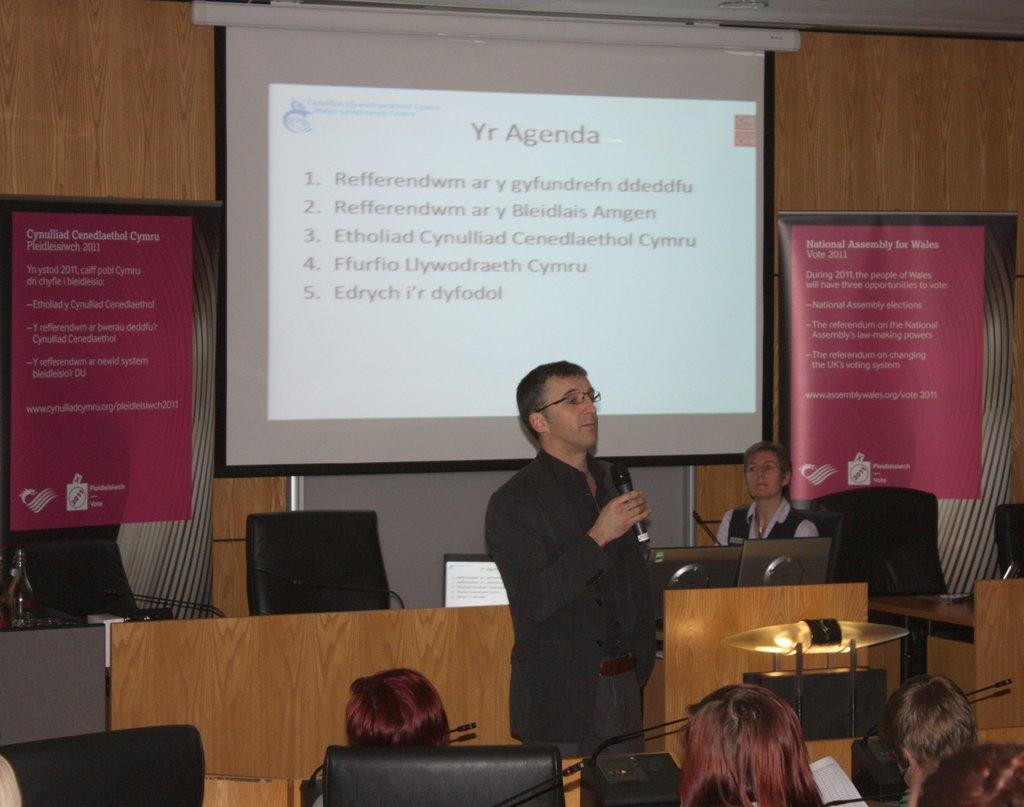In one or two sentences, can you explain what this image depicts? In this image there is one person standing and wearing a black color suit and holding a Mic in middle of this image. There are some chairs on the left side of this image and there are some chairs on the right side of this image. There is one person sitting on the chair at right side of this image, and there is a screen on the top of this image, and there is a wall in the background. There are some objects kept on the bottom left corner of this image. 